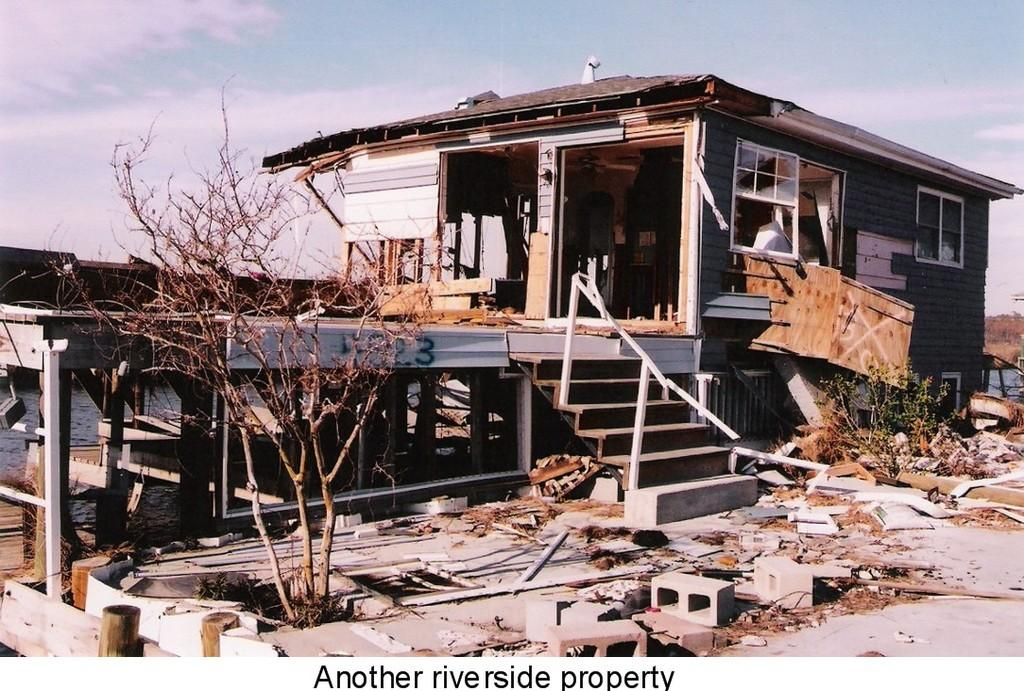What type of structure is in the foreground of the image? There is a wooden house in the foreground of the image. What else can be seen in the foreground of the image besides the wooden house? There are plants and water visible in the foreground of the image. What is visible at the top of the image? The sky is visible at the top of the image. When was the image taken? The image was taken during the day. What type of tomatoes are growing on the roof of the wooden house in the image? There are no tomatoes visible on the roof of the wooden house in the image. What curve can be seen in the image? There is no curve mentioned or visible in the image. 